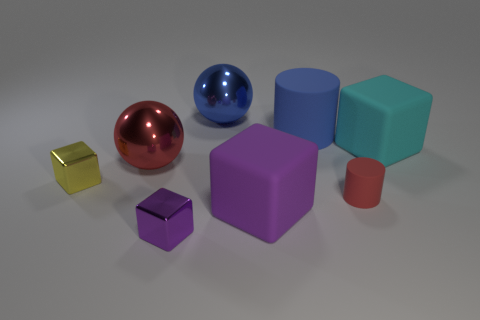Which objects in the image could potentially float on water? Looking at the materials, the blue and red spheres, along with the red cylinder, appear to be hollow and might be capable of floating due to the enclosed air. The solidity or hollowness of objects isn't visually confirmed, but if they are hollow, these objects may float. 